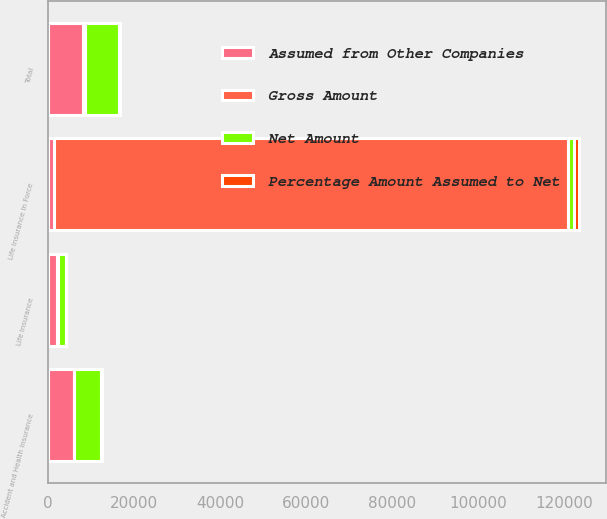Convert chart. <chart><loc_0><loc_0><loc_500><loc_500><stacked_bar_chart><ecel><fcel>Life Insurance in Force<fcel>Life Insurance<fcel>Accident and Health Insurance<fcel>Total<nl><fcel>Assumed from Other Companies<fcel>1484.55<fcel>2077.4<fcel>6005.2<fcel>8082.6<nl><fcel>Gross Amount<fcel>119225<fcel>329<fcel>129.7<fcel>458.7<nl><fcel>Percentage Amount Assumed to Net<fcel>1208<fcel>12.7<fcel>311.6<fcel>324.3<nl><fcel>Net Amount<fcel>1484.55<fcel>1761.1<fcel>6187.1<fcel>7948.2<nl></chart> 